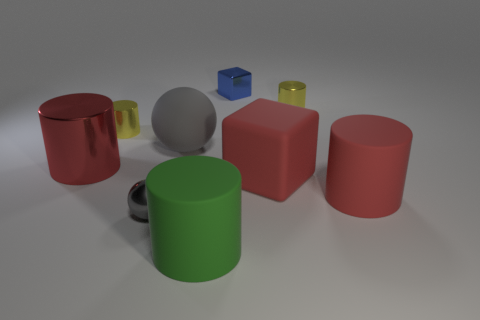How many brown things are matte objects or big shiny objects?
Ensure brevity in your answer.  0. What material is the other object that is the same shape as the small blue metallic object?
Keep it short and to the point. Rubber. There is a big thing left of the gray matte object; what is its shape?
Your answer should be compact. Cylinder. Is there a yellow cylinder that has the same material as the big green cylinder?
Keep it short and to the point. No. Is the green object the same size as the rubber cube?
Your answer should be compact. Yes. How many cylinders are either large green things or brown things?
Your answer should be very brief. 1. What material is the cylinder that is the same color as the large metal object?
Your answer should be compact. Rubber. How many big gray things are the same shape as the large red metal object?
Give a very brief answer. 0. Is the number of balls that are to the right of the gray matte object greater than the number of blue objects in front of the red metal object?
Your answer should be very brief. No. There is a shiny sphere that is left of the blue metallic cube; is its color the same as the small metal cube?
Make the answer very short. No. 